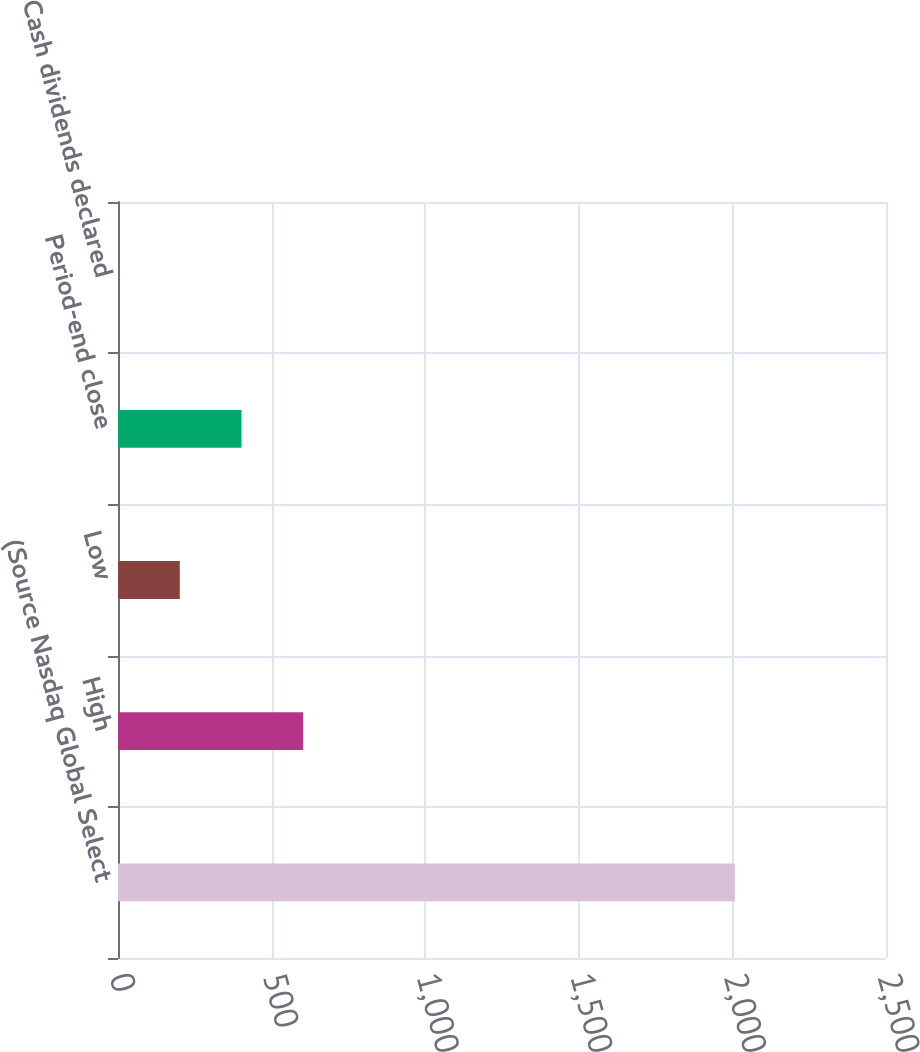<chart> <loc_0><loc_0><loc_500><loc_500><bar_chart><fcel>(Source Nasdaq Global Select<fcel>High<fcel>Low<fcel>Period-end close<fcel>Cash dividends declared<nl><fcel>2008<fcel>602.67<fcel>201.15<fcel>401.91<fcel>0.39<nl></chart> 